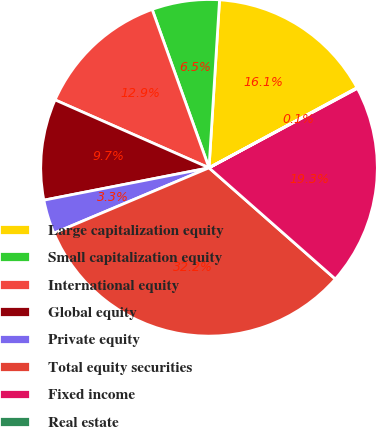Convert chart to OTSL. <chart><loc_0><loc_0><loc_500><loc_500><pie_chart><fcel>Large capitalization equity<fcel>Small capitalization equity<fcel>International equity<fcel>Global equity<fcel>Private equity<fcel>Total equity securities<fcel>Fixed income<fcel>Real estate<nl><fcel>16.11%<fcel>6.48%<fcel>12.9%<fcel>9.69%<fcel>3.27%<fcel>32.16%<fcel>19.32%<fcel>0.06%<nl></chart> 